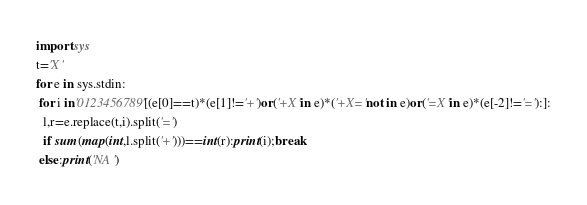<code> <loc_0><loc_0><loc_500><loc_500><_Python_>import sys
t='X'
for e in sys.stdin:
 for i in'0123456789'[(e[0]==t)*(e[1]!='+')or('+X'in e)*('+X='not in e)or('=X'in e)*(e[-2]!='='):]:
  l,r=e.replace(t,i).split('=')
  if sum(map(int,l.split('+')))==int(r):print(i);break
 else:print('NA')
</code> 